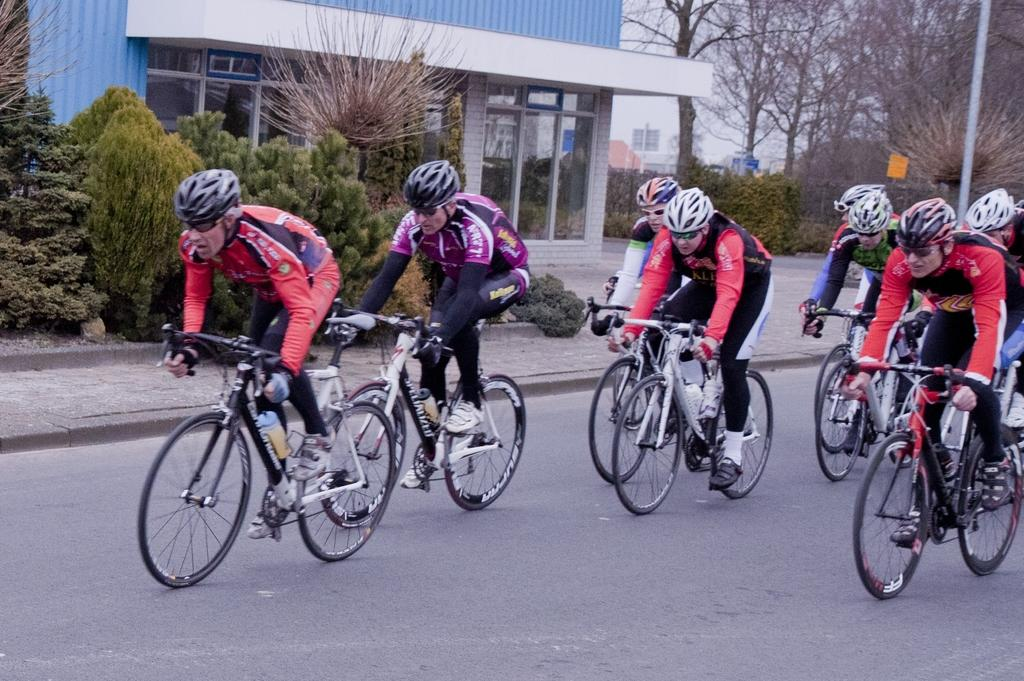How many people are in the image? There is a group of people in the image. What protective gear are the people wearing? The people are wearing helmets and goggles. What activity are the people engaged in? The people are riding bicycles. Where are the bicycles located? A: The bicycles are on the road. What can be seen in the background of the image? There are trees, buildings, poles, and some objects in the background of the image. What type of trousers are the people wearing while riding the bicycles? The provided facts do not mention the type of trousers the people are wearing. However, it is not possible to determine the type of trousers from the image alone. --- Facts: 1. There is a car in the image. 2. The car is red. 3. The car has four wheels. 4. The car has a license plate. 5. The car has a sunroof. 6. The car has a rearview mirror. 7. The car has a steering wheel. 8. The car has a dashboard. 9. The car has a windshield. Absurd Topics: parrot, sand, umbrella Conversation: What is the color of the car in the image? The car is red. How many wheels does the car have? The car has four wheels. What features can be seen on the car? The car has a license plate, sunroof, rearview mirror, steering wheel, dashboard, and windshield. Reasoning: Let's think step by step in order to produce the conversation. We start by identifying the main subject in the image, which is the car. Then, we expand the conversation to include details about the car's color, number of wheels, and specific features. Each question is designed to elicit a specific detail about the image that is known from the provided facts. Absurd Question/Answer: Can you see a parrot sitting on the car's dashboard in the image? No, there is no parrot visible on the car's dashboard in the image. 